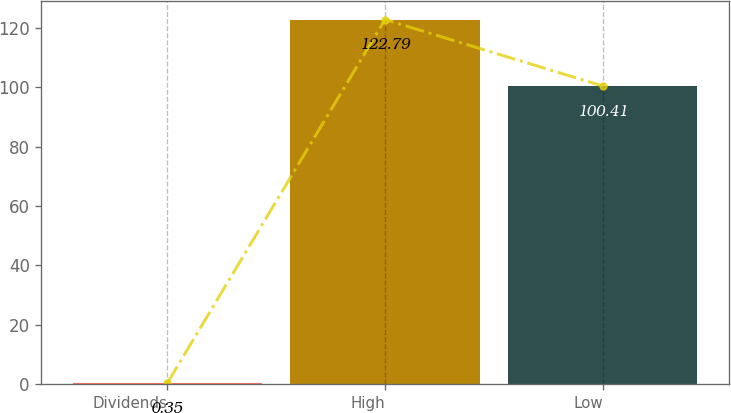Convert chart. <chart><loc_0><loc_0><loc_500><loc_500><bar_chart><fcel>Dividends<fcel>High<fcel>Low<nl><fcel>0.35<fcel>122.79<fcel>100.41<nl></chart> 